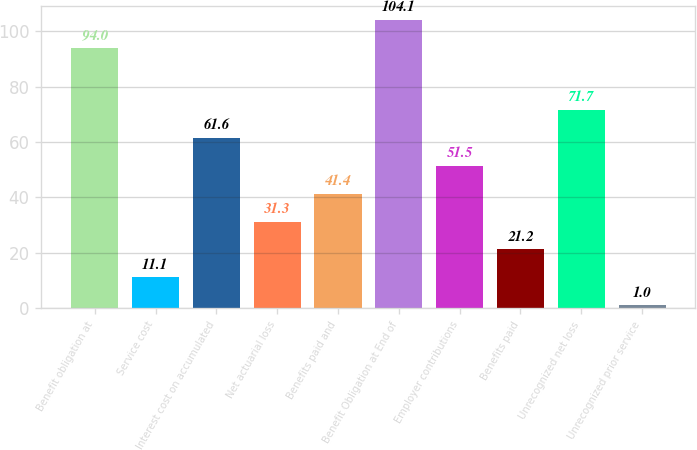Convert chart. <chart><loc_0><loc_0><loc_500><loc_500><bar_chart><fcel>Benefit obligation at<fcel>Service cost<fcel>Interest cost on accumulated<fcel>Net actuarial loss<fcel>Benefits paid and<fcel>Benefit Obligation at End of<fcel>Employer contributions<fcel>Benefits paid<fcel>Unrecognized net loss<fcel>Unrecognized prior service<nl><fcel>94<fcel>11.1<fcel>61.6<fcel>31.3<fcel>41.4<fcel>104.1<fcel>51.5<fcel>21.2<fcel>71.7<fcel>1<nl></chart> 